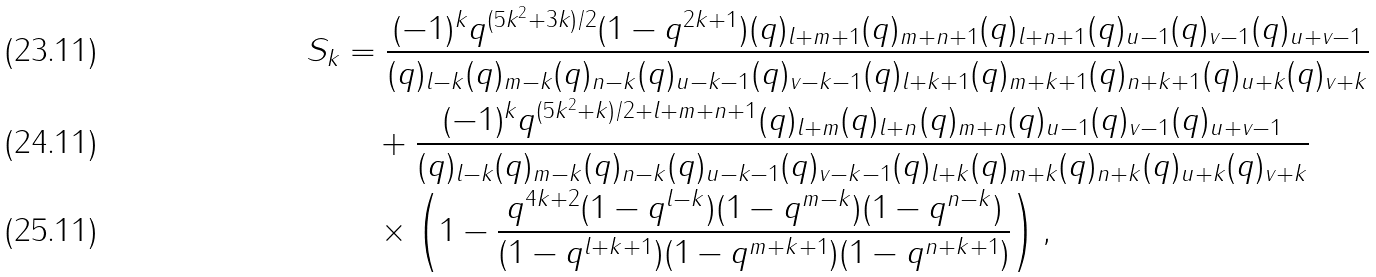<formula> <loc_0><loc_0><loc_500><loc_500>S _ { k } & = \frac { ( - 1 ) ^ { k } q ^ { ( 5 k ^ { 2 } + 3 k ) / 2 } ( 1 - q ^ { 2 k + 1 } ) ( q ) _ { l + m + 1 } ( q ) _ { m + n + 1 } ( q ) _ { l + n + 1 } ( q ) _ { u - 1 } ( q ) _ { v - 1 } ( q ) _ { u + v - 1 } } { ( q ) _ { l - k } ( q ) _ { m - k } ( q ) _ { n - k } ( q ) _ { u - k - 1 } ( q ) _ { v - k - 1 } ( q ) _ { l + k + 1 } ( q ) _ { m + k + 1 } ( q ) _ { n + k + 1 } ( q ) _ { u + k } ( q ) _ { v + k } } \\ & \quad + \frac { ( - 1 ) ^ { k } q ^ { ( 5 k ^ { 2 } + k ) / 2 + l + m + n + 1 } ( q ) _ { l + m } { ( q ) _ { l + n } ( q ) _ { m + n } } ( q ) _ { u - 1 } ( q ) _ { v - 1 } ( q ) _ { u + v - 1 } } { ( q ) _ { l - k } ( q ) _ { m - k } ( q ) _ { n - k } ( q ) _ { u - k - 1 } ( q ) _ { v - k - 1 } ( q ) _ { l + k } ( q ) _ { m + k } ( q ) _ { n + k } ( q ) _ { u + k } ( q ) _ { v + k } } \\ & \quad \times \left ( 1 - \frac { q ^ { 4 k + 2 } ( 1 - q ^ { l - k } ) ( 1 - q ^ { m - k } ) ( 1 - q ^ { n - k } ) } { ( 1 - q ^ { l + k + 1 } ) ( 1 - q ^ { m + k + 1 } ) ( 1 - q ^ { n + k + 1 } ) } \right ) ,</formula> 